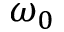<formula> <loc_0><loc_0><loc_500><loc_500>\omega _ { 0 }</formula> 